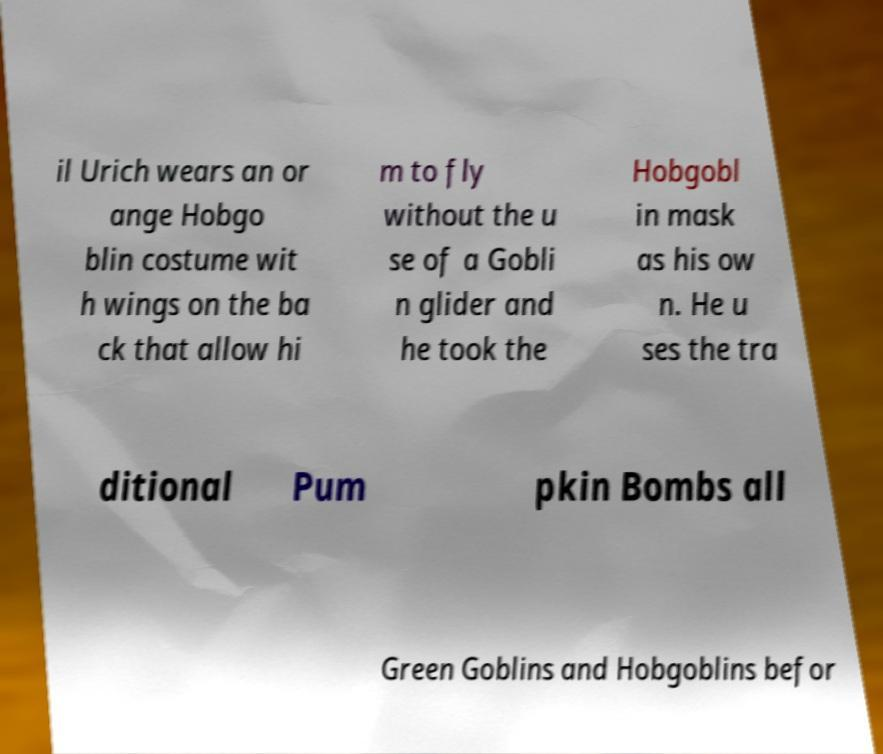For documentation purposes, I need the text within this image transcribed. Could you provide that? il Urich wears an or ange Hobgo blin costume wit h wings on the ba ck that allow hi m to fly without the u se of a Gobli n glider and he took the Hobgobl in mask as his ow n. He u ses the tra ditional Pum pkin Bombs all Green Goblins and Hobgoblins befor 